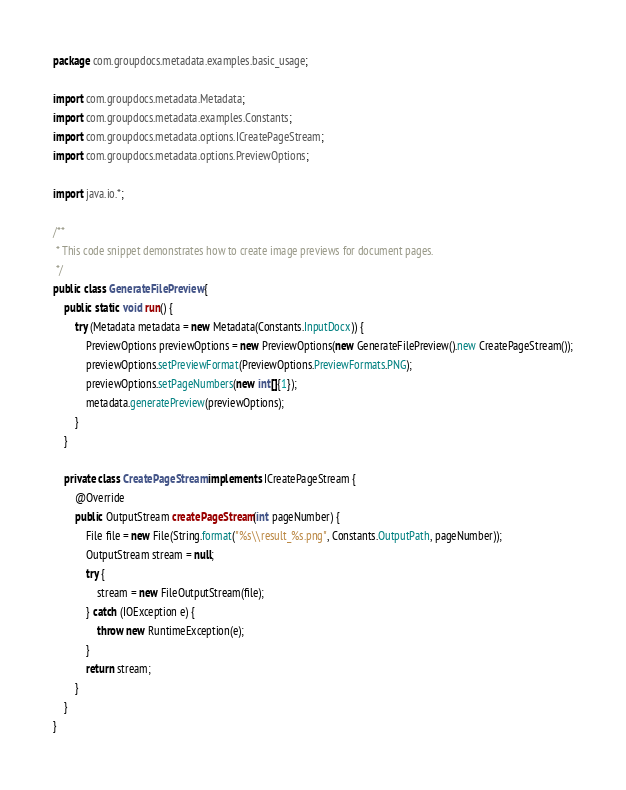<code> <loc_0><loc_0><loc_500><loc_500><_Java_>
package com.groupdocs.metadata.examples.basic_usage;

import com.groupdocs.metadata.Metadata;
import com.groupdocs.metadata.examples.Constants;
import com.groupdocs.metadata.options.ICreatePageStream;
import com.groupdocs.metadata.options.PreviewOptions;

import java.io.*;

/**
 * This code snippet demonstrates how to create image previews for document pages.
 */
public class GenerateFilePreview {
    public static void run() {
        try (Metadata metadata = new Metadata(Constants.InputDocx)) {
            PreviewOptions previewOptions = new PreviewOptions(new GenerateFilePreview().new CreatePageStream());
            previewOptions.setPreviewFormat(PreviewOptions.PreviewFormats.PNG);
            previewOptions.setPageNumbers(new int[]{1});
            metadata.generatePreview(previewOptions);
        }
    }

    private class CreatePageStream implements ICreatePageStream {
        @Override
        public OutputStream createPageStream(int pageNumber) {
            File file = new File(String.format("%s\\result_%s.png", Constants.OutputPath, pageNumber));
            OutputStream stream = null;
            try {
                stream = new FileOutputStream(file);
            } catch (IOException e) {
                throw new RuntimeException(e);
            }
            return stream;
        }
    }
}
</code> 